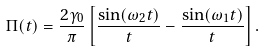Convert formula to latex. <formula><loc_0><loc_0><loc_500><loc_500>\Pi ( t ) = \frac { 2 \gamma _ { 0 } } { \pi } \left [ \frac { \sin ( \omega _ { 2 } t ) } { t } - \frac { \sin ( \omega _ { 1 } t ) } { t } \right ] .</formula> 